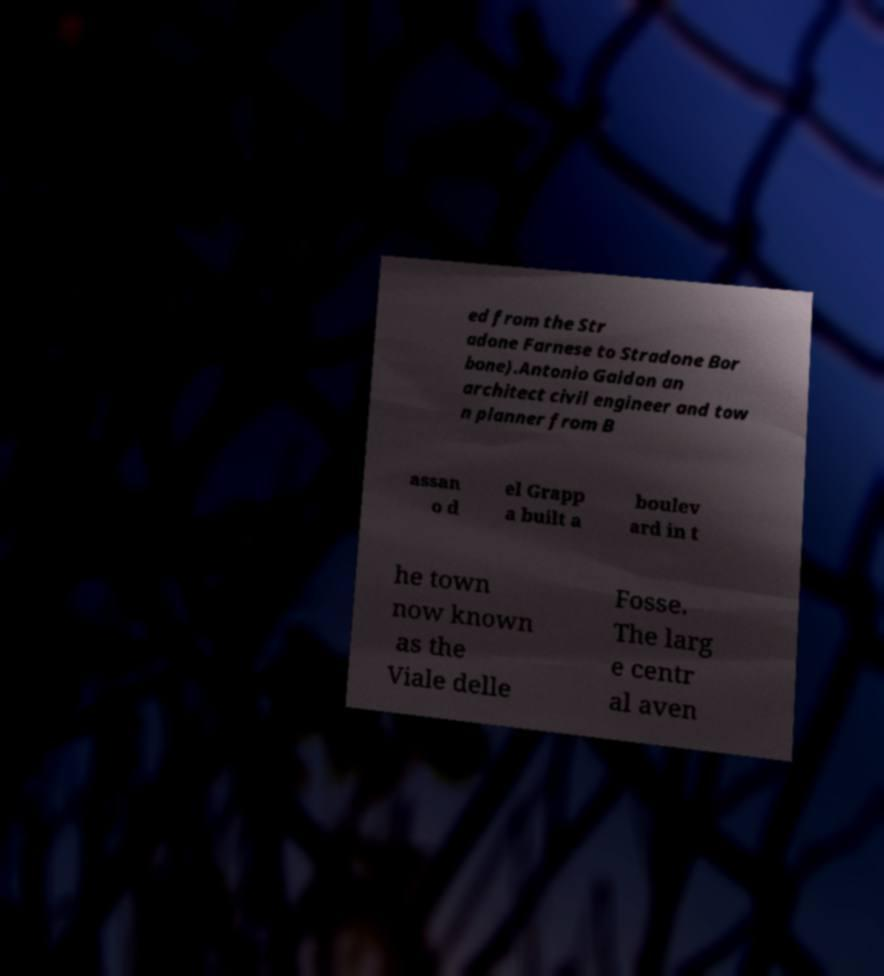Could you assist in decoding the text presented in this image and type it out clearly? ed from the Str adone Farnese to Stradone Bor bone).Antonio Gaidon an architect civil engineer and tow n planner from B assan o d el Grapp a built a boulev ard in t he town now known as the Viale delle Fosse. The larg e centr al aven 